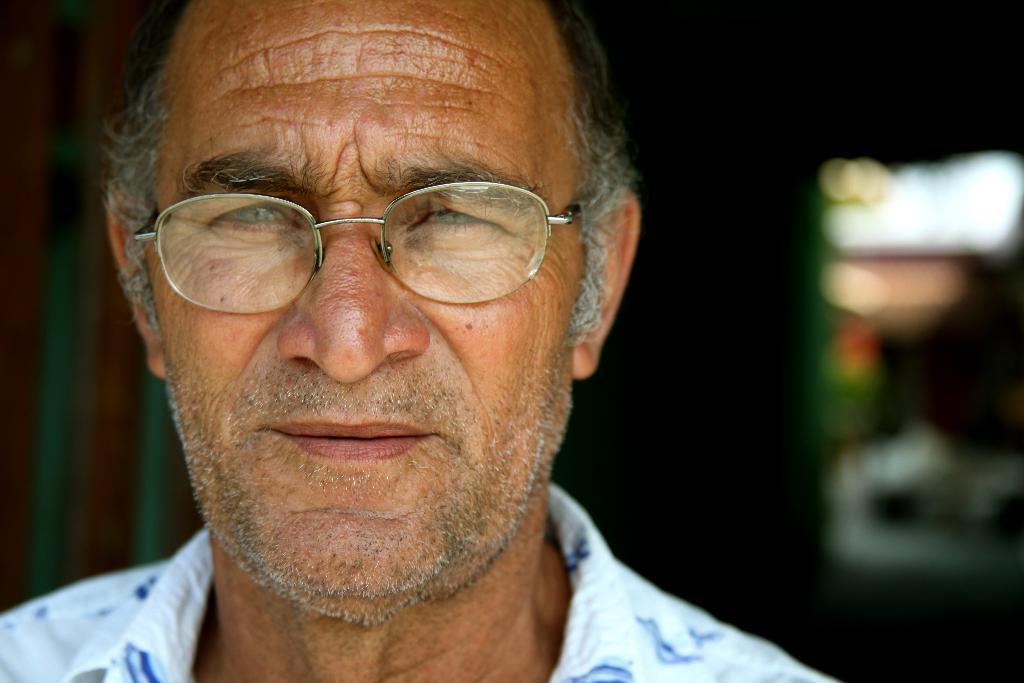How would you summarize this image in a sentence or two? In this image there is a man wearing a spectacle, background is blurry. 